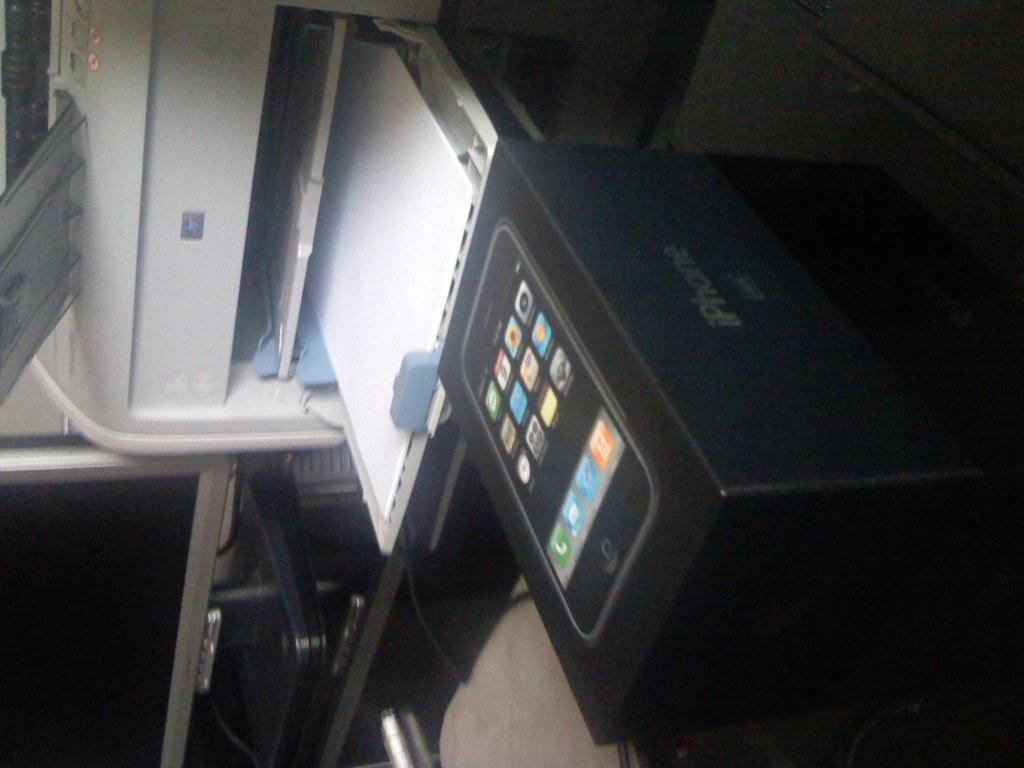<image>
Write a terse but informative summary of the picture. a case that says iPhone on the side 